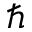<formula> <loc_0><loc_0><loc_500><loc_500>\hbar</formula> 